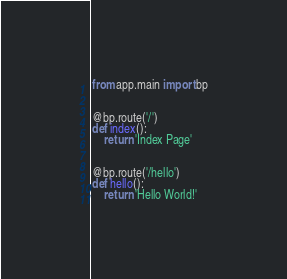<code> <loc_0><loc_0><loc_500><loc_500><_Python_>from app.main import bp


@bp.route('/')
def index():
    return 'Index Page'


@bp.route('/hello')
def hello():
    return 'Hello World!'
</code> 